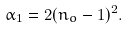Convert formula to latex. <formula><loc_0><loc_0><loc_500><loc_500>\alpha _ { 1 } = 2 ( n _ { o } - 1 ) ^ { 2 } .</formula> 